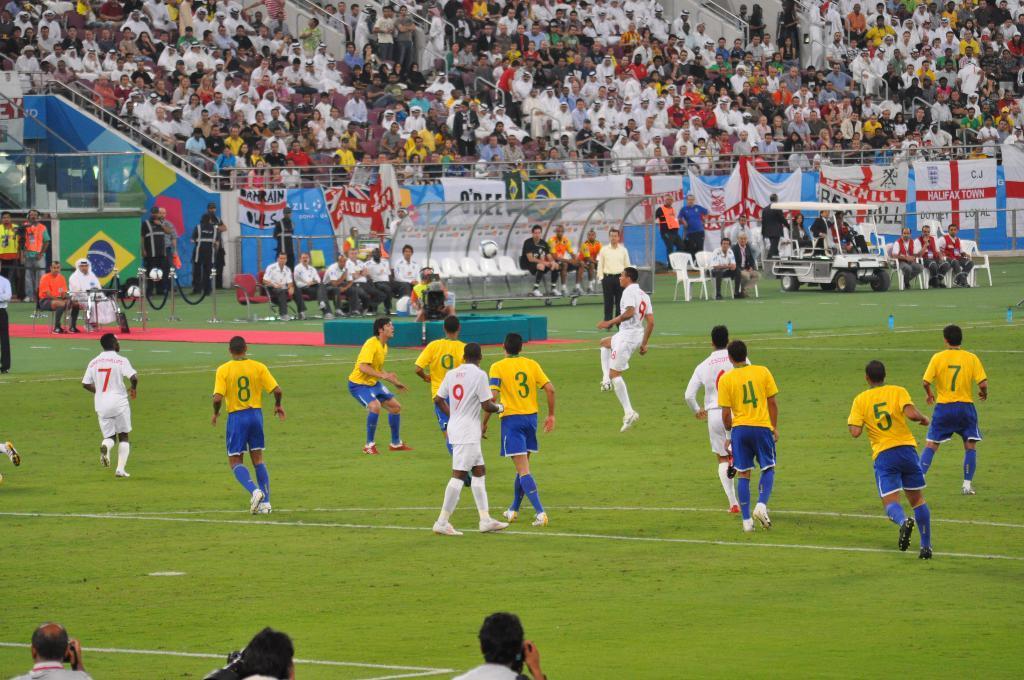Could you give a brief overview of what you see in this image? In the image we can see there are lot of people standing on the ground. There are other people sitting on the chairs and there are people sitting in the vehicle. There are spectators sitting and watching them. 